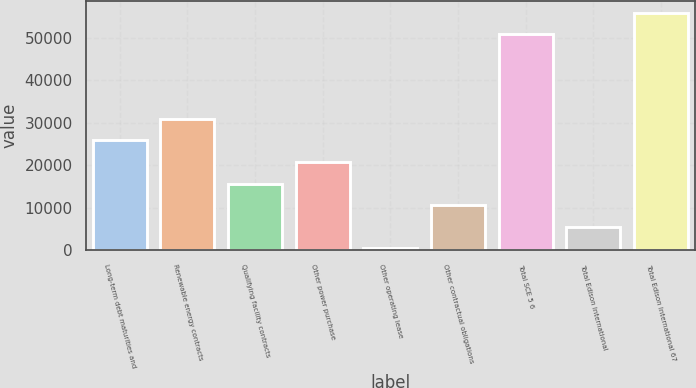<chart> <loc_0><loc_0><loc_500><loc_500><bar_chart><fcel>Long-term debt maturities and<fcel>Renewable energy contracts<fcel>Qualifying facility contracts<fcel>Other power purchase<fcel>Other operating lease<fcel>Other contractual obligations<fcel>Total SCE 5 6<fcel>Total Edison International<fcel>Total Edison International 67<nl><fcel>25843.5<fcel>30921.6<fcel>15687.3<fcel>20765.4<fcel>453<fcel>10609.2<fcel>50774<fcel>5531.1<fcel>55852.1<nl></chart> 